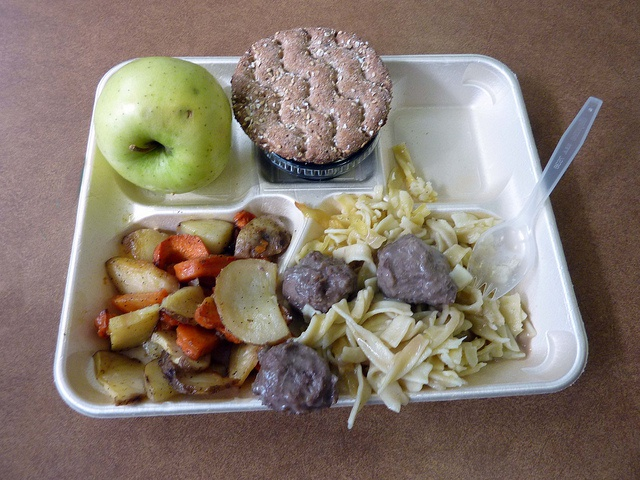Describe the objects in this image and their specific colors. I can see dining table in gray, darkgray, and lightgray tones, cake in gray and darkgray tones, apple in gray, olive, beige, and khaki tones, fork in gray, lavender, and darkgray tones, and carrot in gray, maroon, brown, and salmon tones in this image. 